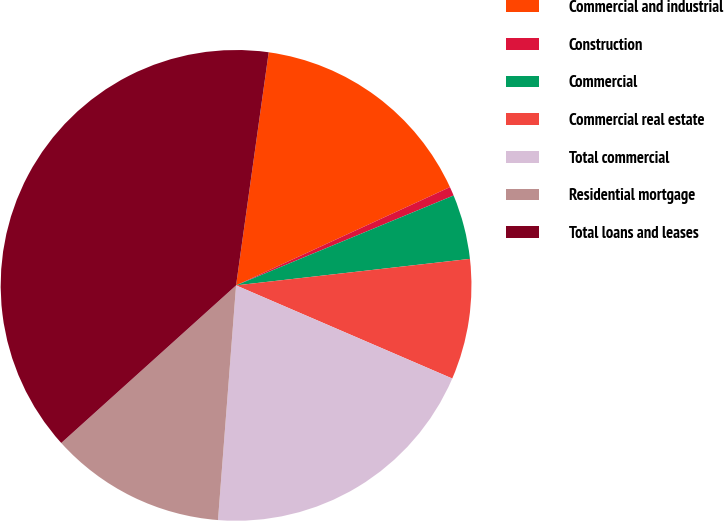Convert chart to OTSL. <chart><loc_0><loc_0><loc_500><loc_500><pie_chart><fcel>Commercial and industrial<fcel>Construction<fcel>Commercial<fcel>Commercial real estate<fcel>Total commercial<fcel>Residential mortgage<fcel>Total loans and leases<nl><fcel>15.93%<fcel>0.62%<fcel>4.44%<fcel>8.27%<fcel>19.75%<fcel>12.1%<fcel>38.89%<nl></chart> 